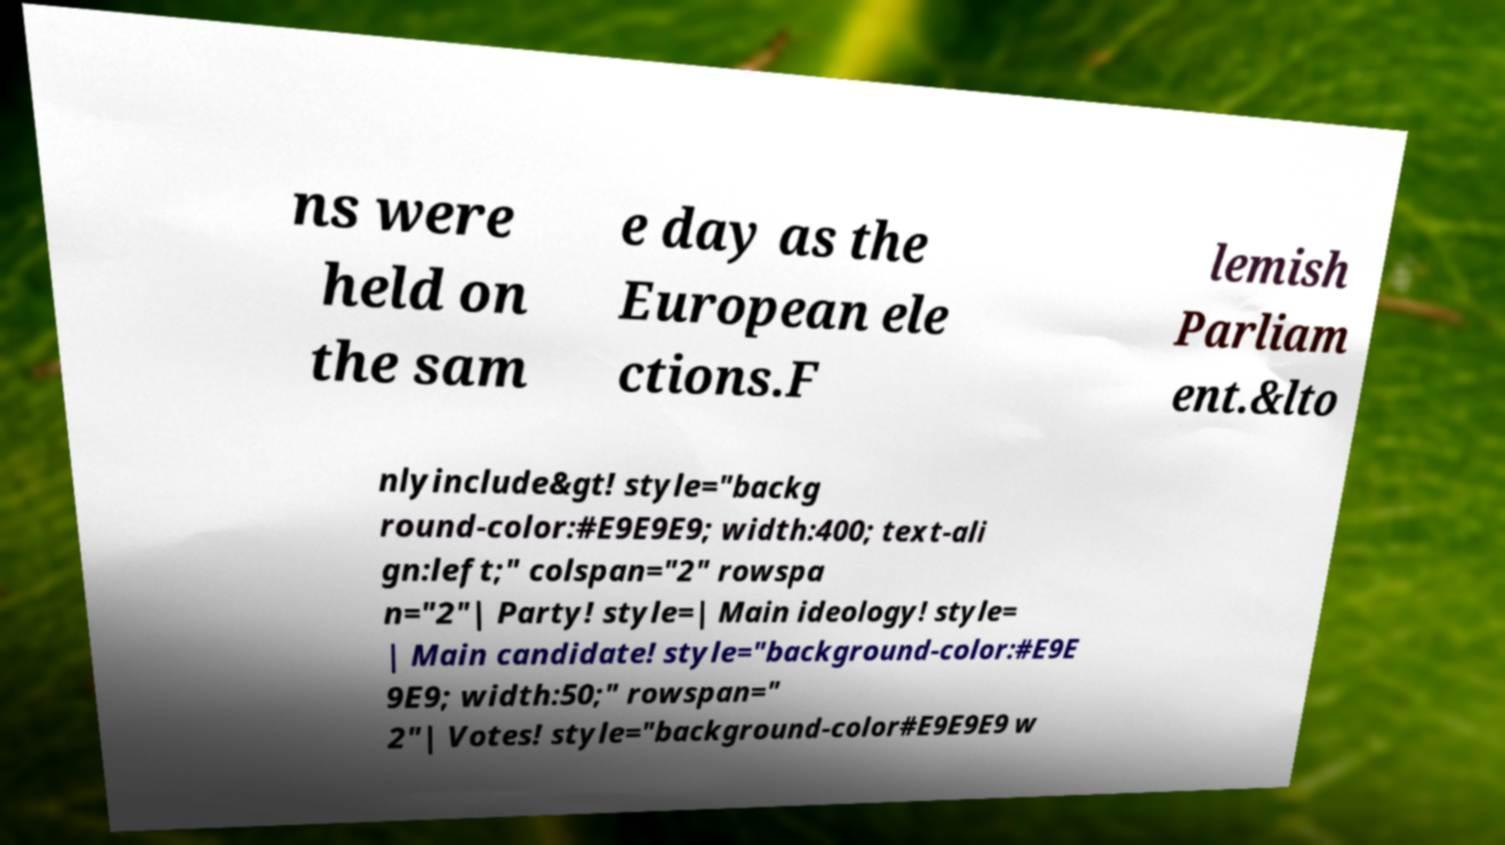Please identify and transcribe the text found in this image. ns were held on the sam e day as the European ele ctions.F lemish Parliam ent.&lto nlyinclude&gt! style="backg round-color:#E9E9E9; width:400; text-ali gn:left;" colspan="2" rowspa n="2"| Party! style=| Main ideology! style= | Main candidate! style="background-color:#E9E 9E9; width:50;" rowspan=" 2"| Votes! style="background-color#E9E9E9 w 